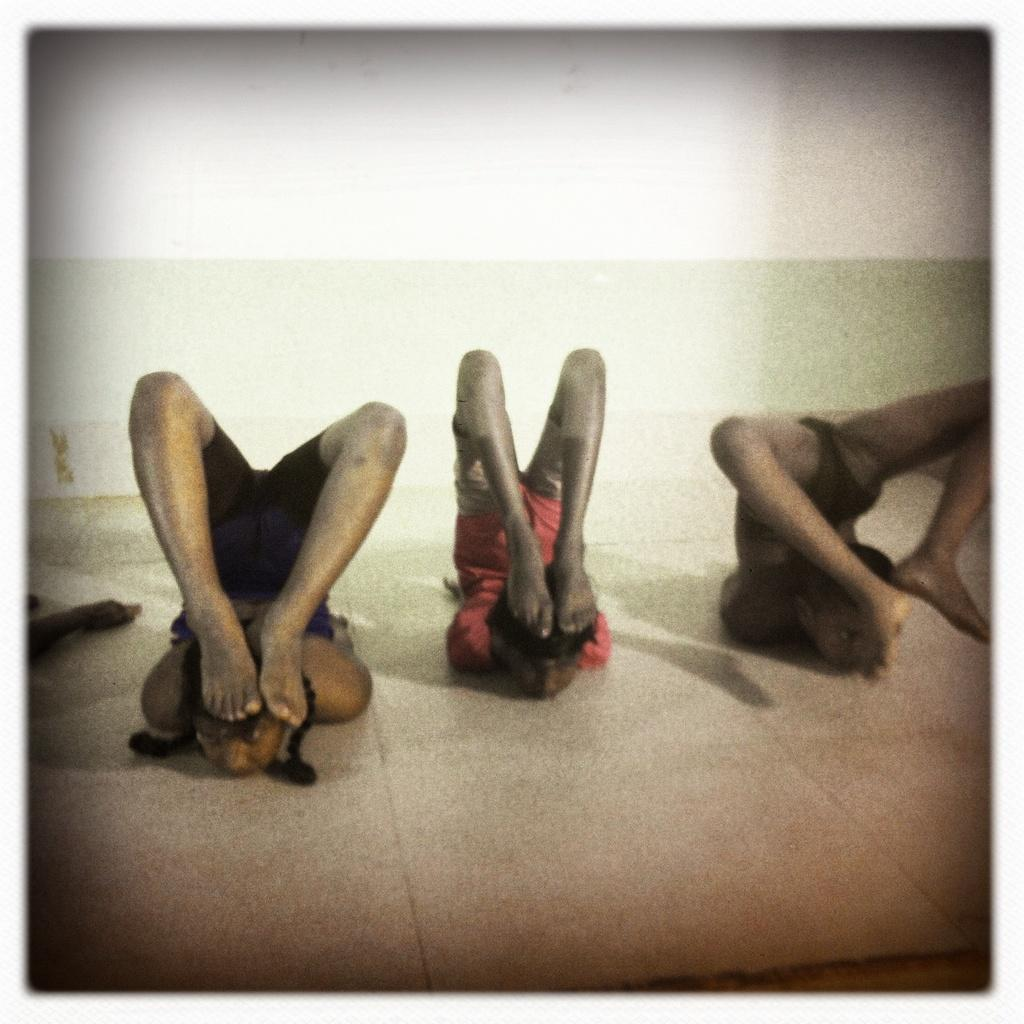What are the three people in the image doing? The three people in the image are performing yoga. Can you describe the object on the left side of the image? Unfortunately, the provided facts do not mention any specific details about the object on the left side of the image. What can be seen in the background of the image? There is a wall in the background of the image. What type of impulse can be seen affecting the group of people in the image? There is no indication of any impulse affecting the group of people in the image; they are simply performing yoga. Can you tell me how many carts are present in the image? There are no carts present in the image. 